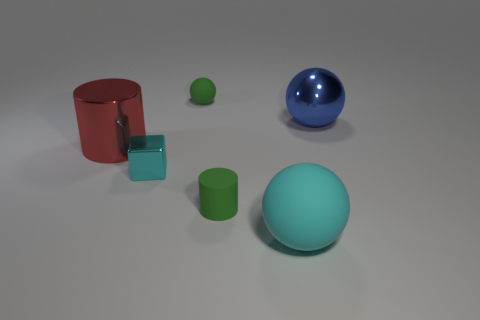There is a matte sphere that is the same size as the matte cylinder; what color is it? green 